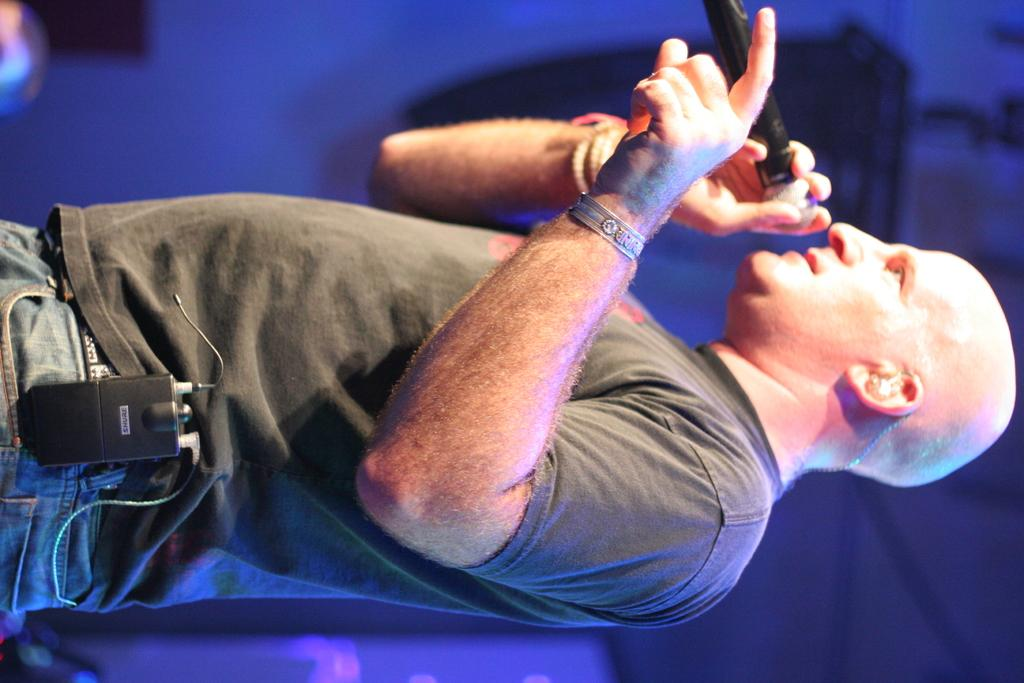What is the person in the image doing? The person in the image is holding a mic. What is the person wearing? The person is wearing a T-shirt. Can you describe the person's action with an object? The person is putting an object in his jeans. What type of bread is the person using as a prop in the image? There is no bread present in the image. 